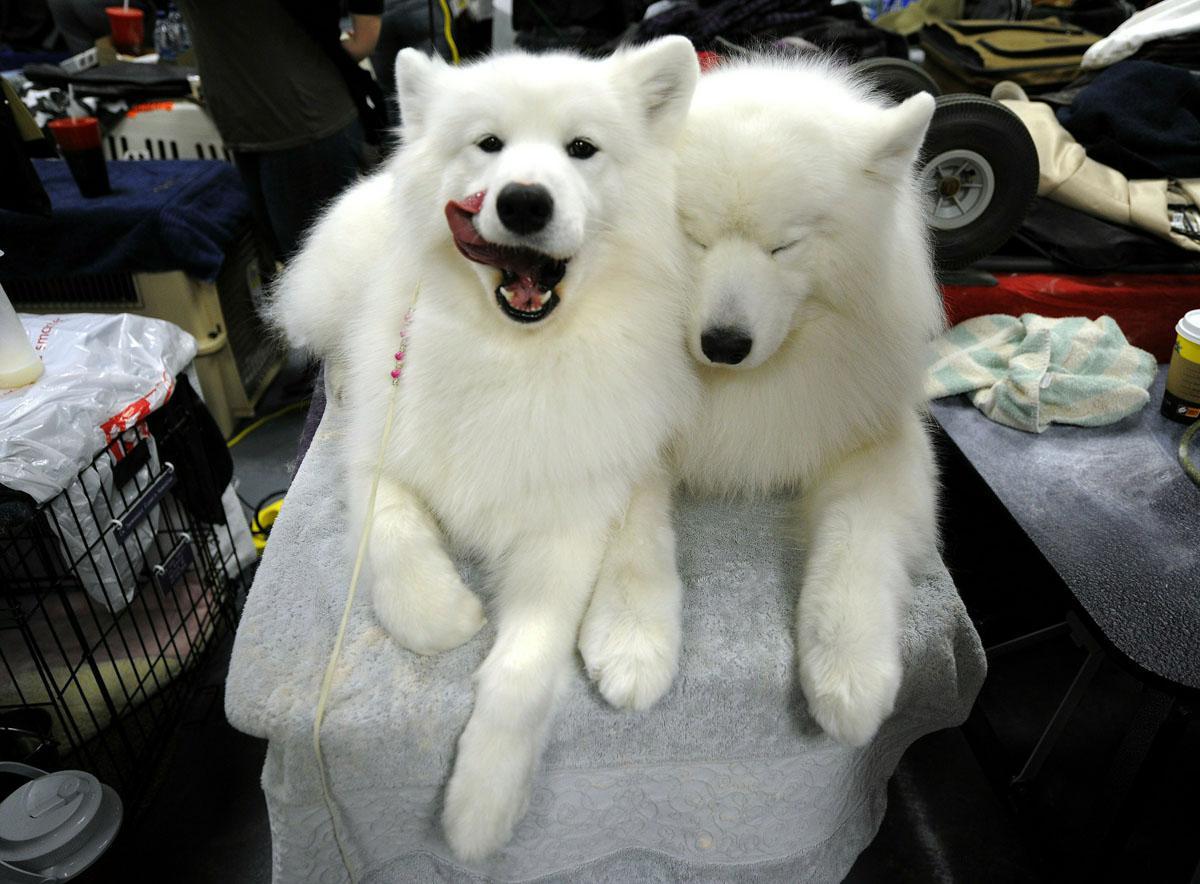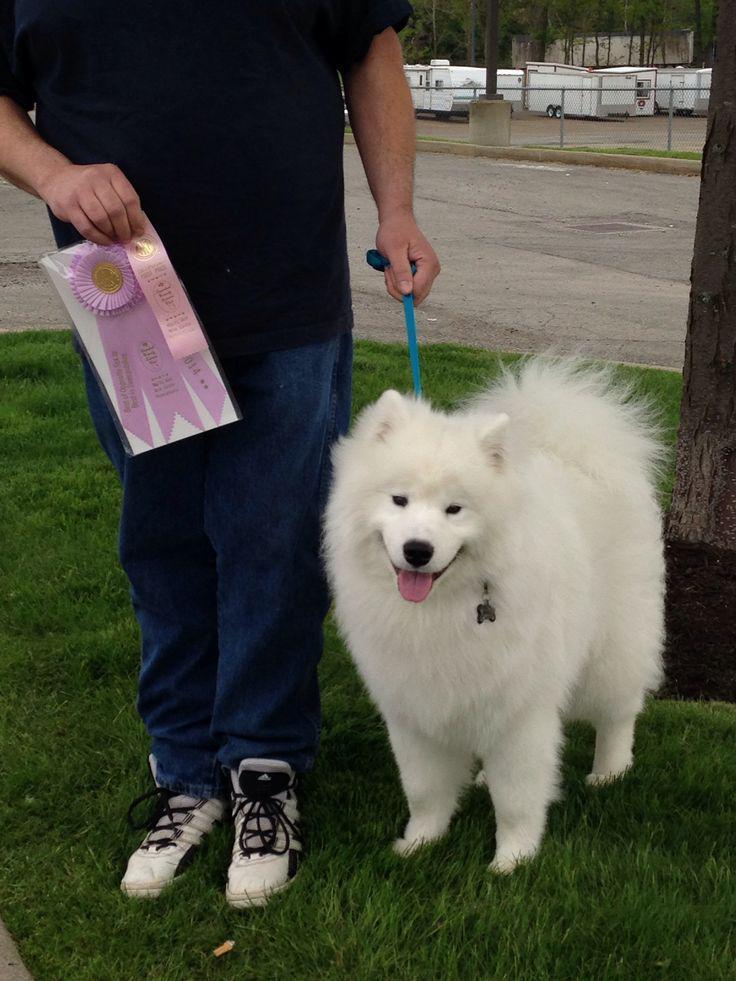The first image is the image on the left, the second image is the image on the right. Examine the images to the left and right. Is the description "A white dog is wearing an orange and black Halloween costume that has a matching hat." accurate? Answer yes or no. No. The first image is the image on the left, the second image is the image on the right. Given the left and right images, does the statement "at least one dog is dressed in costume" hold true? Answer yes or no. No. 